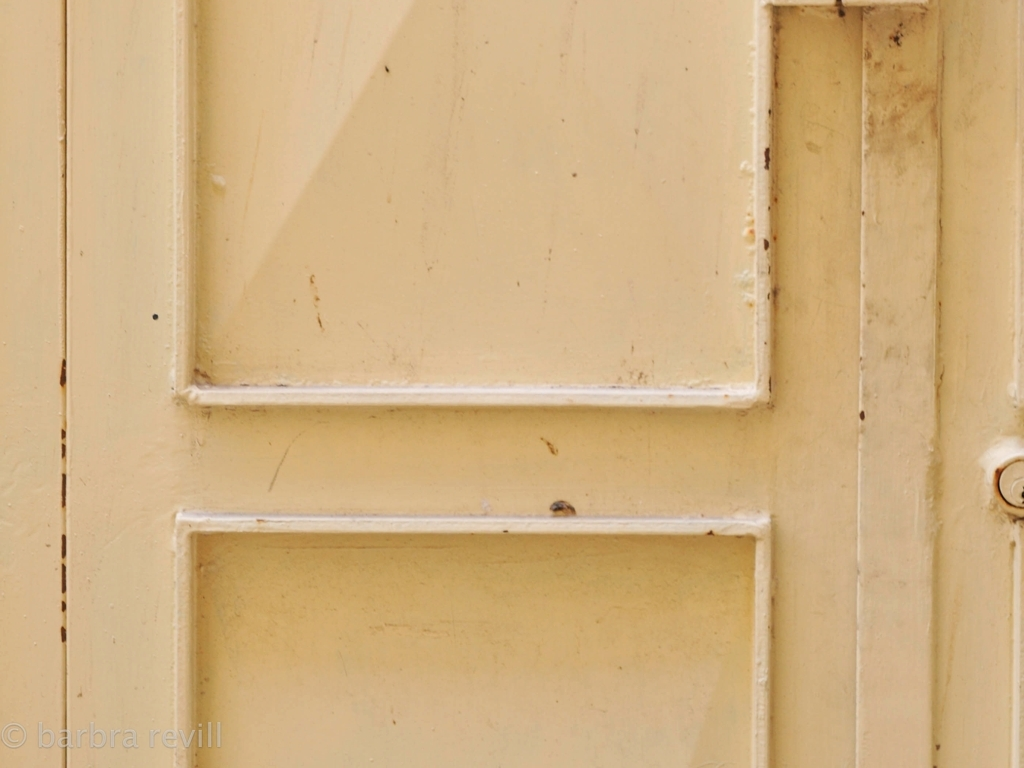Can you describe the color and texture of the door? The door is a creamy beige color with a smooth but weathered texture. It shows signs of age with scratches, scuffs, and discoloration, particularly around the edges and raised panels, where the paint has worn down to reveal the material beneath. 